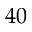Convert formula to latex. <formula><loc_0><loc_0><loc_500><loc_500>4 0</formula> 